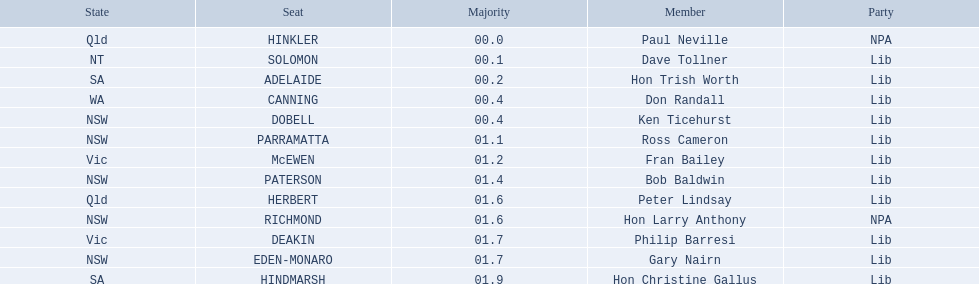Who are all the lib party members? Dave Tollner, Hon Trish Worth, Don Randall, Ken Ticehurst, Ross Cameron, Fran Bailey, Bob Baldwin, Peter Lindsay, Philip Barresi, Gary Nairn, Hon Christine Gallus. What lib party members are in sa? Hon Trish Worth, Hon Christine Gallus. What is the highest difference in majority between members in sa? 01.9. 